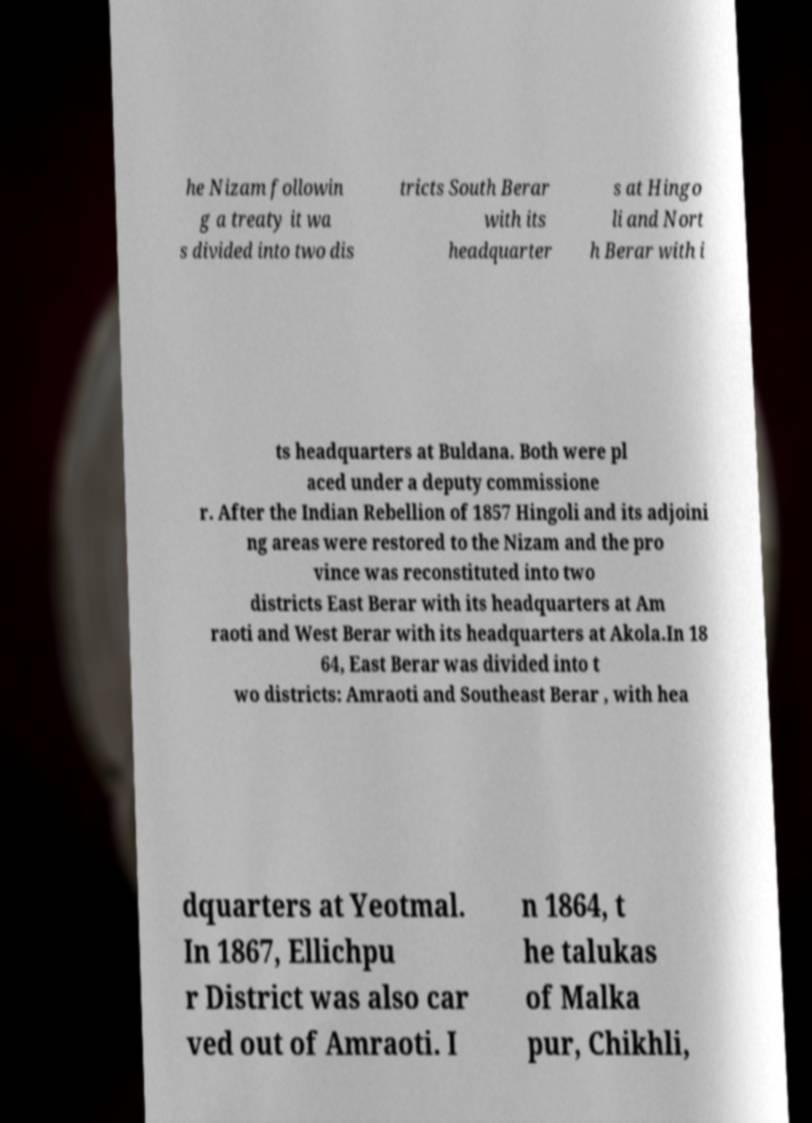Could you assist in decoding the text presented in this image and type it out clearly? he Nizam followin g a treaty it wa s divided into two dis tricts South Berar with its headquarter s at Hingo li and Nort h Berar with i ts headquarters at Buldana. Both were pl aced under a deputy commissione r. After the Indian Rebellion of 1857 Hingoli and its adjoini ng areas were restored to the Nizam and the pro vince was reconstituted into two districts East Berar with its headquarters at Am raoti and West Berar with its headquarters at Akola.In 18 64, East Berar was divided into t wo districts: Amraoti and Southeast Berar , with hea dquarters at Yeotmal. In 1867, Ellichpu r District was also car ved out of Amraoti. I n 1864, t he talukas of Malka pur, Chikhli, 